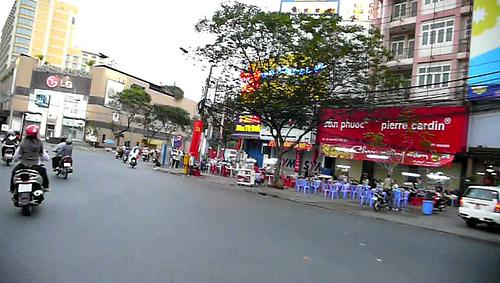Why is the motorcycle rider wearing a red helmet? Please explain your reasoning. protection. This rider is wearing a helmet probably because he has seen other bikers get really bad skull injuries at some point, so he's going to do what he can to protect his head. 